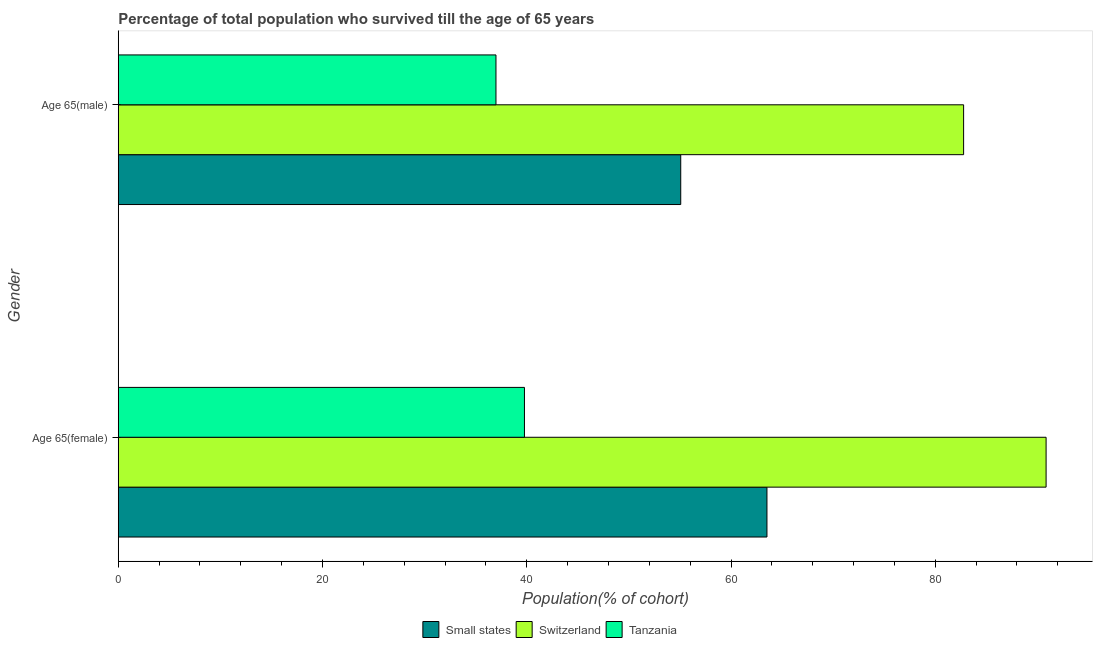How many bars are there on the 1st tick from the top?
Offer a terse response. 3. What is the label of the 2nd group of bars from the top?
Offer a terse response. Age 65(female). What is the percentage of female population who survived till age of 65 in Switzerland?
Ensure brevity in your answer.  90.86. Across all countries, what is the maximum percentage of male population who survived till age of 65?
Offer a very short reply. 82.78. Across all countries, what is the minimum percentage of female population who survived till age of 65?
Provide a short and direct response. 39.77. In which country was the percentage of female population who survived till age of 65 maximum?
Your response must be concise. Switzerland. In which country was the percentage of male population who survived till age of 65 minimum?
Ensure brevity in your answer.  Tanzania. What is the total percentage of female population who survived till age of 65 in the graph?
Provide a short and direct response. 194.15. What is the difference between the percentage of female population who survived till age of 65 in Tanzania and that in Switzerland?
Make the answer very short. -51.08. What is the difference between the percentage of male population who survived till age of 65 in Switzerland and the percentage of female population who survived till age of 65 in Tanzania?
Provide a short and direct response. 43. What is the average percentage of female population who survived till age of 65 per country?
Offer a terse response. 64.72. What is the difference between the percentage of male population who survived till age of 65 and percentage of female population who survived till age of 65 in Tanzania?
Provide a succinct answer. -2.79. What is the ratio of the percentage of female population who survived till age of 65 in Small states to that in Switzerland?
Provide a short and direct response. 0.7. In how many countries, is the percentage of male population who survived till age of 65 greater than the average percentage of male population who survived till age of 65 taken over all countries?
Your response must be concise. 1. What does the 3rd bar from the top in Age 65(male) represents?
Offer a very short reply. Small states. What does the 3rd bar from the bottom in Age 65(female) represents?
Provide a short and direct response. Tanzania. How many bars are there?
Give a very brief answer. 6. How many countries are there in the graph?
Your answer should be compact. 3. Are the values on the major ticks of X-axis written in scientific E-notation?
Keep it short and to the point. No. Does the graph contain any zero values?
Your answer should be compact. No. Where does the legend appear in the graph?
Keep it short and to the point. Bottom center. How many legend labels are there?
Ensure brevity in your answer.  3. How are the legend labels stacked?
Offer a very short reply. Horizontal. What is the title of the graph?
Offer a terse response. Percentage of total population who survived till the age of 65 years. What is the label or title of the X-axis?
Your answer should be compact. Population(% of cohort). What is the Population(% of cohort) of Small states in Age 65(female)?
Provide a succinct answer. 63.52. What is the Population(% of cohort) in Switzerland in Age 65(female)?
Offer a very short reply. 90.86. What is the Population(% of cohort) in Tanzania in Age 65(female)?
Offer a very short reply. 39.77. What is the Population(% of cohort) of Small states in Age 65(male)?
Your answer should be compact. 55.08. What is the Population(% of cohort) in Switzerland in Age 65(male)?
Your answer should be compact. 82.78. What is the Population(% of cohort) of Tanzania in Age 65(male)?
Your response must be concise. 36.98. Across all Gender, what is the maximum Population(% of cohort) of Small states?
Give a very brief answer. 63.52. Across all Gender, what is the maximum Population(% of cohort) of Switzerland?
Offer a terse response. 90.86. Across all Gender, what is the maximum Population(% of cohort) in Tanzania?
Make the answer very short. 39.77. Across all Gender, what is the minimum Population(% of cohort) of Small states?
Provide a succinct answer. 55.08. Across all Gender, what is the minimum Population(% of cohort) of Switzerland?
Offer a terse response. 82.78. Across all Gender, what is the minimum Population(% of cohort) of Tanzania?
Provide a short and direct response. 36.98. What is the total Population(% of cohort) of Small states in the graph?
Make the answer very short. 118.6. What is the total Population(% of cohort) in Switzerland in the graph?
Your answer should be very brief. 173.64. What is the total Population(% of cohort) in Tanzania in the graph?
Your response must be concise. 76.76. What is the difference between the Population(% of cohort) in Small states in Age 65(female) and that in Age 65(male)?
Offer a terse response. 8.44. What is the difference between the Population(% of cohort) of Switzerland in Age 65(female) and that in Age 65(male)?
Your response must be concise. 8.08. What is the difference between the Population(% of cohort) in Tanzania in Age 65(female) and that in Age 65(male)?
Provide a succinct answer. 2.79. What is the difference between the Population(% of cohort) in Small states in Age 65(female) and the Population(% of cohort) in Switzerland in Age 65(male)?
Your response must be concise. -19.26. What is the difference between the Population(% of cohort) in Small states in Age 65(female) and the Population(% of cohort) in Tanzania in Age 65(male)?
Provide a succinct answer. 26.54. What is the difference between the Population(% of cohort) in Switzerland in Age 65(female) and the Population(% of cohort) in Tanzania in Age 65(male)?
Ensure brevity in your answer.  53.87. What is the average Population(% of cohort) of Small states per Gender?
Your answer should be compact. 59.3. What is the average Population(% of cohort) in Switzerland per Gender?
Give a very brief answer. 86.82. What is the average Population(% of cohort) in Tanzania per Gender?
Ensure brevity in your answer.  38.38. What is the difference between the Population(% of cohort) of Small states and Population(% of cohort) of Switzerland in Age 65(female)?
Provide a succinct answer. -27.34. What is the difference between the Population(% of cohort) of Small states and Population(% of cohort) of Tanzania in Age 65(female)?
Offer a very short reply. 23.75. What is the difference between the Population(% of cohort) in Switzerland and Population(% of cohort) in Tanzania in Age 65(female)?
Provide a short and direct response. 51.08. What is the difference between the Population(% of cohort) of Small states and Population(% of cohort) of Switzerland in Age 65(male)?
Give a very brief answer. -27.7. What is the difference between the Population(% of cohort) of Small states and Population(% of cohort) of Tanzania in Age 65(male)?
Provide a succinct answer. 18.09. What is the difference between the Population(% of cohort) of Switzerland and Population(% of cohort) of Tanzania in Age 65(male)?
Keep it short and to the point. 45.79. What is the ratio of the Population(% of cohort) of Small states in Age 65(female) to that in Age 65(male)?
Provide a succinct answer. 1.15. What is the ratio of the Population(% of cohort) in Switzerland in Age 65(female) to that in Age 65(male)?
Give a very brief answer. 1.1. What is the ratio of the Population(% of cohort) of Tanzania in Age 65(female) to that in Age 65(male)?
Offer a terse response. 1.08. What is the difference between the highest and the second highest Population(% of cohort) of Small states?
Your response must be concise. 8.44. What is the difference between the highest and the second highest Population(% of cohort) in Switzerland?
Your answer should be very brief. 8.08. What is the difference between the highest and the second highest Population(% of cohort) in Tanzania?
Offer a terse response. 2.79. What is the difference between the highest and the lowest Population(% of cohort) of Small states?
Your response must be concise. 8.44. What is the difference between the highest and the lowest Population(% of cohort) in Switzerland?
Provide a short and direct response. 8.08. What is the difference between the highest and the lowest Population(% of cohort) in Tanzania?
Offer a terse response. 2.79. 